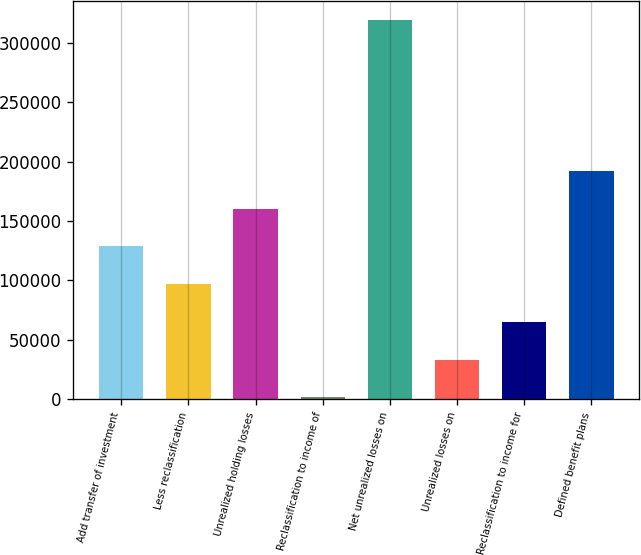Convert chart. <chart><loc_0><loc_0><loc_500><loc_500><bar_chart><fcel>Add transfer of investment<fcel>Less reclassification<fcel>Unrealized holding losses<fcel>Reclassification to income of<fcel>Net unrealized losses on<fcel>Unrealized losses on<fcel>Reclassification to income for<fcel>Defined benefit plans<nl><fcel>128603<fcel>96906.6<fcel>160299<fcel>1818<fcel>318780<fcel>33514.2<fcel>65210.4<fcel>191995<nl></chart> 